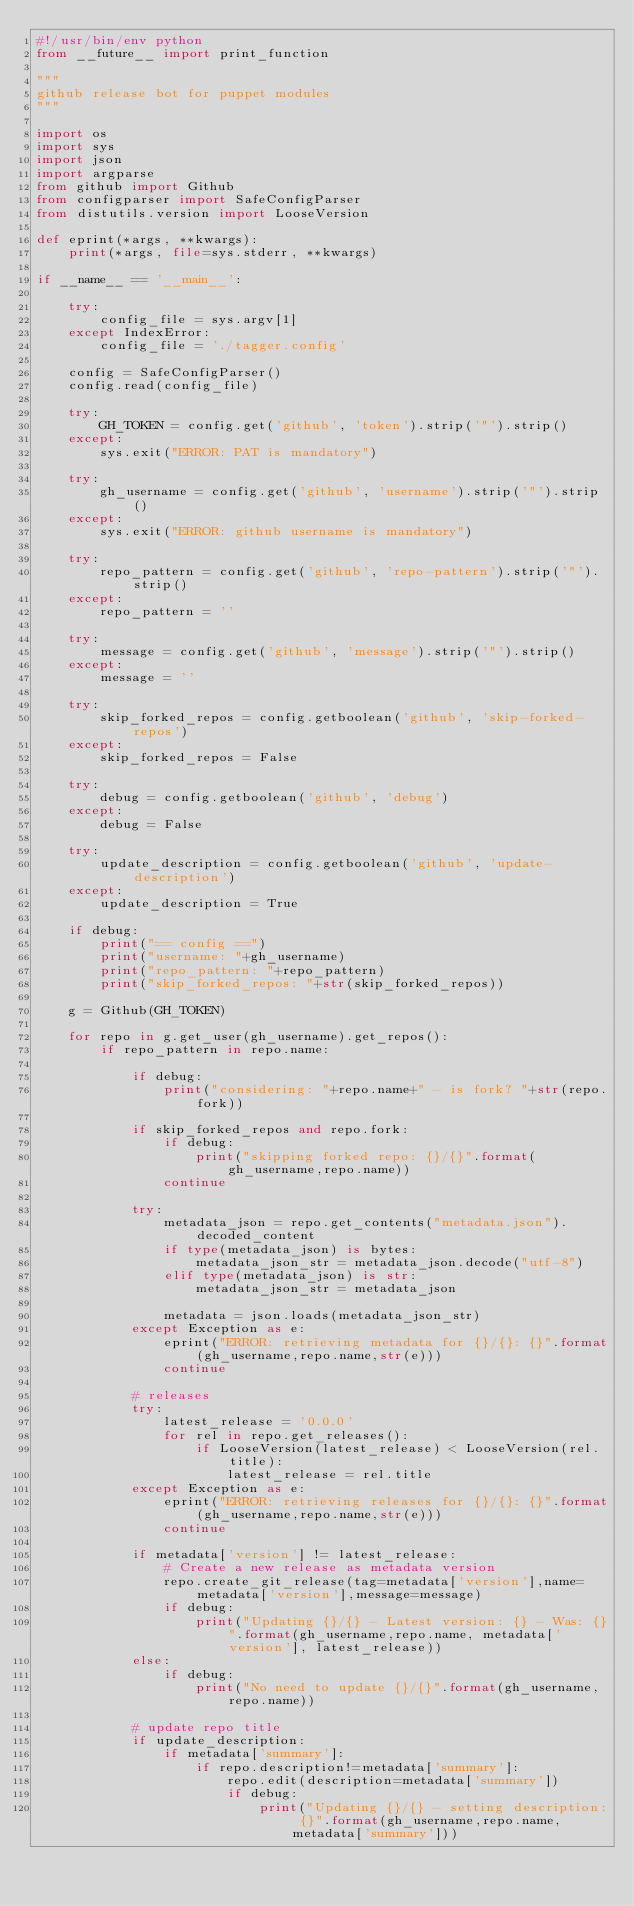Convert code to text. <code><loc_0><loc_0><loc_500><loc_500><_Python_>#!/usr/bin/env python
from __future__ import print_function

"""
github release bot for puppet modules
"""

import os
import sys
import json
import argparse
from github import Github
from configparser import SafeConfigParser
from distutils.version import LooseVersion

def eprint(*args, **kwargs):
    print(*args, file=sys.stderr, **kwargs)

if __name__ == '__main__':

    try:
        config_file = sys.argv[1]
    except IndexError:
        config_file = './tagger.config'

    config = SafeConfigParser()
    config.read(config_file)

    try:
        GH_TOKEN = config.get('github', 'token').strip('"').strip()
    except:
        sys.exit("ERROR: PAT is mandatory")

    try:
        gh_username = config.get('github', 'username').strip('"').strip()
    except:
        sys.exit("ERROR: github username is mandatory")

    try:
        repo_pattern = config.get('github', 'repo-pattern').strip('"').strip()
    except:
        repo_pattern = ''

    try:
        message = config.get('github', 'message').strip('"').strip()
    except:
        message = ''

    try:
        skip_forked_repos = config.getboolean('github', 'skip-forked-repos')
    except:
        skip_forked_repos = False

    try:
        debug = config.getboolean('github', 'debug')
    except:
        debug = False

    try:
        update_description = config.getboolean('github', 'update-description')
    except:
        update_description = True

    if debug:
        print("== config ==")
        print("username: "+gh_username)
        print("repo_pattern: "+repo_pattern)
        print("skip_forked_repos: "+str(skip_forked_repos))

    g = Github(GH_TOKEN)

    for repo in g.get_user(gh_username).get_repos():
        if repo_pattern in repo.name:

            if debug:
                print("considering: "+repo.name+" - is fork? "+str(repo.fork))

            if skip_forked_repos and repo.fork:
                if debug:
                    print("skipping forked repo: {}/{}".format(gh_username,repo.name))
                continue

            try:
                metadata_json = repo.get_contents("metadata.json").decoded_content
                if type(metadata_json) is bytes:
                    metadata_json_str = metadata_json.decode("utf-8")
                elif type(metadata_json) is str:
                    metadata_json_str = metadata_json

                metadata = json.loads(metadata_json_str)
            except Exception as e:
                eprint("ERROR: retrieving metadata for {}/{}: {}".format(gh_username,repo.name,str(e)))
                continue

            # releases
            try:
                latest_release = '0.0.0'
                for rel in repo.get_releases():
                    if LooseVersion(latest_release) < LooseVersion(rel.title):
                        latest_release = rel.title
            except Exception as e:
                eprint("ERROR: retrieving releases for {}/{}: {}".format(gh_username,repo.name,str(e)))
                continue

            if metadata['version'] != latest_release:
                # Create a new release as metadata version
                repo.create_git_release(tag=metadata['version'],name=metadata['version'],message=message)
                if debug:
                    print("Updating {}/{} - Latest version: {} - Was: {}".format(gh_username,repo.name, metadata['version'], latest_release))
            else:
                if debug:
                    print("No need to update {}/{}".format(gh_username,repo.name))

            # update repo title
            if update_description:
                if metadata['summary']:
                    if repo.description!=metadata['summary']:
                        repo.edit(description=metadata['summary'])
                        if debug:
                            print("Updating {}/{} - setting description: {}".format(gh_username,repo.name, metadata['summary']))
</code> 